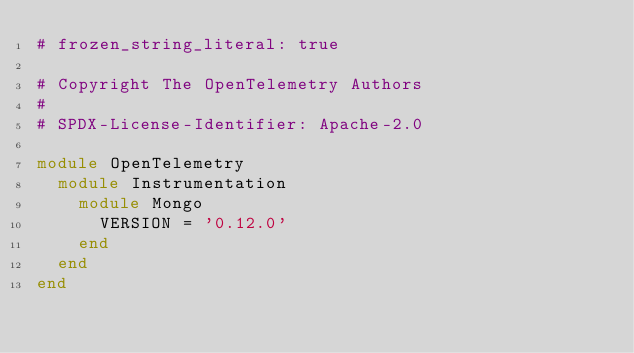Convert code to text. <code><loc_0><loc_0><loc_500><loc_500><_Ruby_># frozen_string_literal: true

# Copyright The OpenTelemetry Authors
#
# SPDX-License-Identifier: Apache-2.0

module OpenTelemetry
  module Instrumentation
    module Mongo
      VERSION = '0.12.0'
    end
  end
end
</code> 